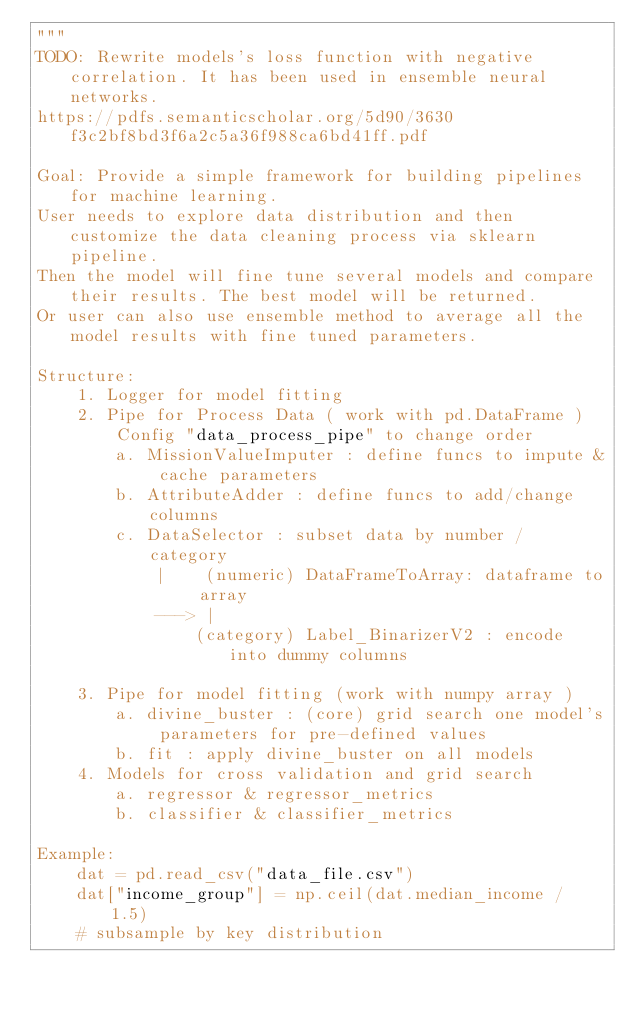<code> <loc_0><loc_0><loc_500><loc_500><_Python_>"""
TODO: Rewrite models's loss function with negative correlation. It has been used in ensemble neural networks.
https://pdfs.semanticscholar.org/5d90/3630f3c2bf8bd3f6a2c5a36f988ca6bd41ff.pdf

Goal: Provide a simple framework for building pipelines for machine learning.
User needs to explore data distribution and then customize the data cleaning process via sklearn pipeline.
Then the model will fine tune several models and compare their results. The best model will be returned.
Or user can also use ensemble method to average all the model results with fine tuned parameters.

Structure:
    1. Logger for model fitting
    2. Pipe for Process Data ( work with pd.DataFrame )
        Config "data_process_pipe" to change order
        a. MissionValueImputer : define funcs to impute & cache parameters
        b. AttributeAdder : define funcs to add/change columns
        c. DataSelector : subset data by number / category
            |    (numeric) DataFrameToArray: dataframe to array
            ---> |
                (category) Label_BinarizerV2 : encode into dummy columns

    3. Pipe for model fitting (work with numpy array )
        a. divine_buster : (core) grid search one model's parameters for pre-defined values
        b. fit : apply divine_buster on all models
    4. Models for cross validation and grid search
        a. regressor & regressor_metrics
        b. classifier & classifier_metrics

Example:
    dat = pd.read_csv("data_file.csv")
    dat["income_group"] = np.ceil(dat.median_income / 1.5)
    # subsample by key distribution</code> 